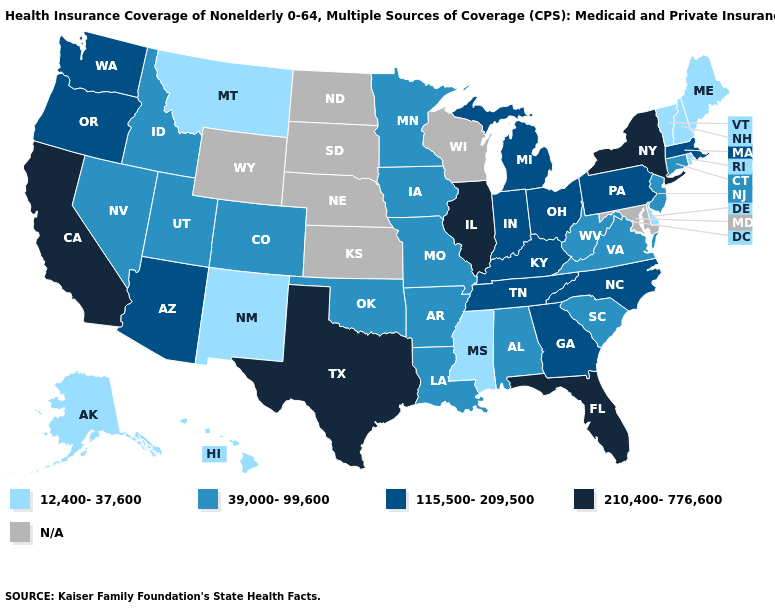What is the value of Oregon?
Answer briefly. 115,500-209,500. What is the value of Minnesota?
Write a very short answer. 39,000-99,600. Among the states that border Utah , does Arizona have the highest value?
Give a very brief answer. Yes. Name the states that have a value in the range 39,000-99,600?
Write a very short answer. Alabama, Arkansas, Colorado, Connecticut, Idaho, Iowa, Louisiana, Minnesota, Missouri, Nevada, New Jersey, Oklahoma, South Carolina, Utah, Virginia, West Virginia. Which states hav the highest value in the West?
Short answer required. California. What is the highest value in the West ?
Be succinct. 210,400-776,600. What is the highest value in the West ?
Keep it brief. 210,400-776,600. What is the value of New Hampshire?
Concise answer only. 12,400-37,600. What is the value of Oregon?
Answer briefly. 115,500-209,500. Which states have the highest value in the USA?
Quick response, please. California, Florida, Illinois, New York, Texas. What is the lowest value in states that border South Carolina?
Write a very short answer. 115,500-209,500. Name the states that have a value in the range 39,000-99,600?
Write a very short answer. Alabama, Arkansas, Colorado, Connecticut, Idaho, Iowa, Louisiana, Minnesota, Missouri, Nevada, New Jersey, Oklahoma, South Carolina, Utah, Virginia, West Virginia. What is the value of Virginia?
Short answer required. 39,000-99,600. What is the value of Florida?
Keep it brief. 210,400-776,600. How many symbols are there in the legend?
Write a very short answer. 5. 